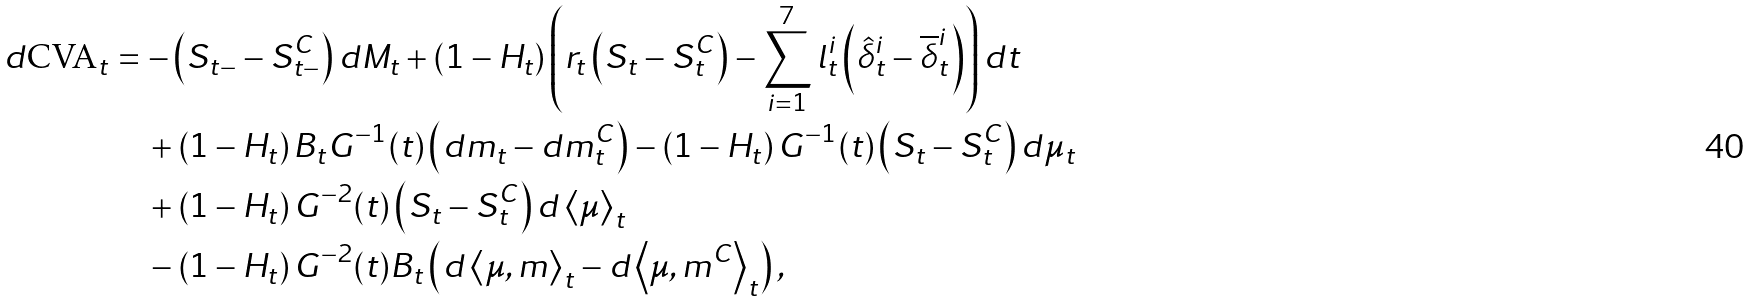Convert formula to latex. <formula><loc_0><loc_0><loc_500><loc_500>d \text {CVA} _ { t } & = - \left ( S _ { t - } - S _ { t - } ^ { C } \right ) d M _ { t } + \left ( 1 - H _ { t } \right ) \left ( r _ { t } \left ( S _ { t } - S _ { t } ^ { C } \right ) - \sum _ { i = 1 } ^ { 7 } l _ { t } ^ { i } \left ( \hat { \delta } _ { t } ^ { i } - \overline { \delta } _ { t } ^ { i } \right ) \right ) d t \\ & \quad + \left ( 1 - H _ { t } \right ) B _ { t } G ^ { - 1 } ( t ) \left ( d m _ { t } - d m _ { t } ^ { C } \right ) - \left ( 1 - H _ { t } \right ) G ^ { - 1 } ( t ) \left ( S _ { t } - S _ { t } ^ { C } \right ) d \mu _ { t } \\ & \quad + \left ( 1 - H _ { t } \right ) G ^ { - 2 } ( t ) \left ( S _ { t } - S _ { t } ^ { C } \right ) d \left \langle \mu \right \rangle _ { t } \\ & \quad - \left ( 1 - H _ { t } \right ) G ^ { - 2 } ( t ) B _ { t } \left ( d \left \langle \mu , m \right \rangle _ { t } - d \left \langle \mu , m ^ { C } \right \rangle _ { t } \right ) ,</formula> 